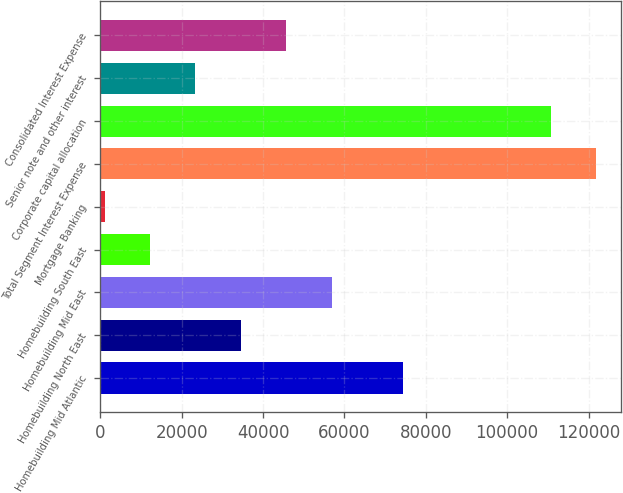<chart> <loc_0><loc_0><loc_500><loc_500><bar_chart><fcel>Homebuilding Mid Atlantic<fcel>Homebuilding North East<fcel>Homebuilding Mid East<fcel>Homebuilding South East<fcel>Mortgage Banking<fcel>Total Segment Interest Expense<fcel>Corporate capital allocation<fcel>Senior note and other interest<fcel>Consolidated Interest Expense<nl><fcel>74293<fcel>34532<fcel>56828<fcel>12236<fcel>1088<fcel>121917<fcel>110769<fcel>23384<fcel>45680<nl></chart> 